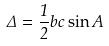<formula> <loc_0><loc_0><loc_500><loc_500>\Delta = \frac { 1 } { 2 } b c \sin A</formula> 